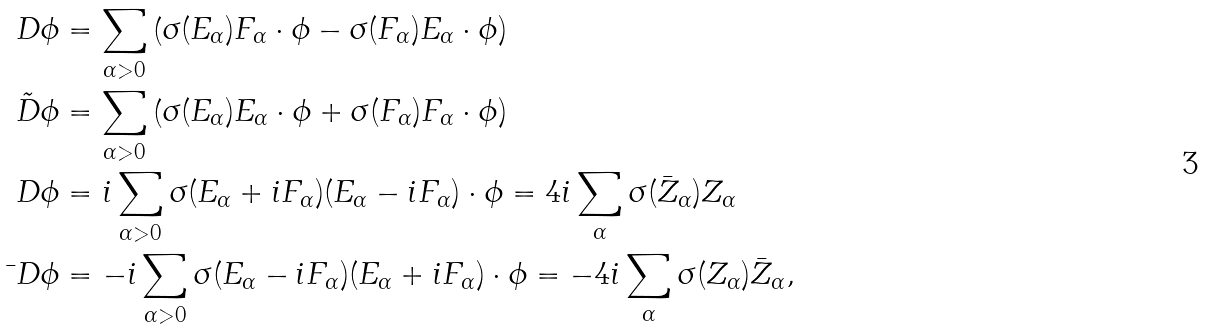Convert formula to latex. <formula><loc_0><loc_0><loc_500><loc_500>D \phi & = \sum _ { \alpha > 0 } \left ( \sigma ( E _ { \alpha } ) F _ { \alpha } \cdot \phi - \sigma ( F _ { \alpha } ) E _ { \alpha } \cdot \phi \right ) \\ \tilde { D } \phi & = \sum _ { \alpha > 0 } \left ( \sigma ( E _ { \alpha } ) E _ { \alpha } \cdot \phi + \sigma ( F _ { \alpha } ) F _ { \alpha } \cdot \phi \right ) \\ \ D \phi & = i \sum _ { \alpha > 0 } \sigma ( E _ { \alpha } + i F _ { \alpha } ) ( E _ { \alpha } - i F _ { \alpha } ) \cdot \phi = 4 i \sum _ { \alpha } \sigma ( \bar { Z } _ { \alpha } ) Z _ { \alpha } \\ \bar { \ } D \phi & = - i \sum _ { \alpha > 0 } \sigma ( E _ { \alpha } - i F _ { \alpha } ) ( E _ { \alpha } + i F _ { \alpha } ) \cdot \phi = - 4 i \sum _ { \alpha } \sigma ( Z _ { \alpha } ) \bar { Z } _ { \alpha } ,</formula> 